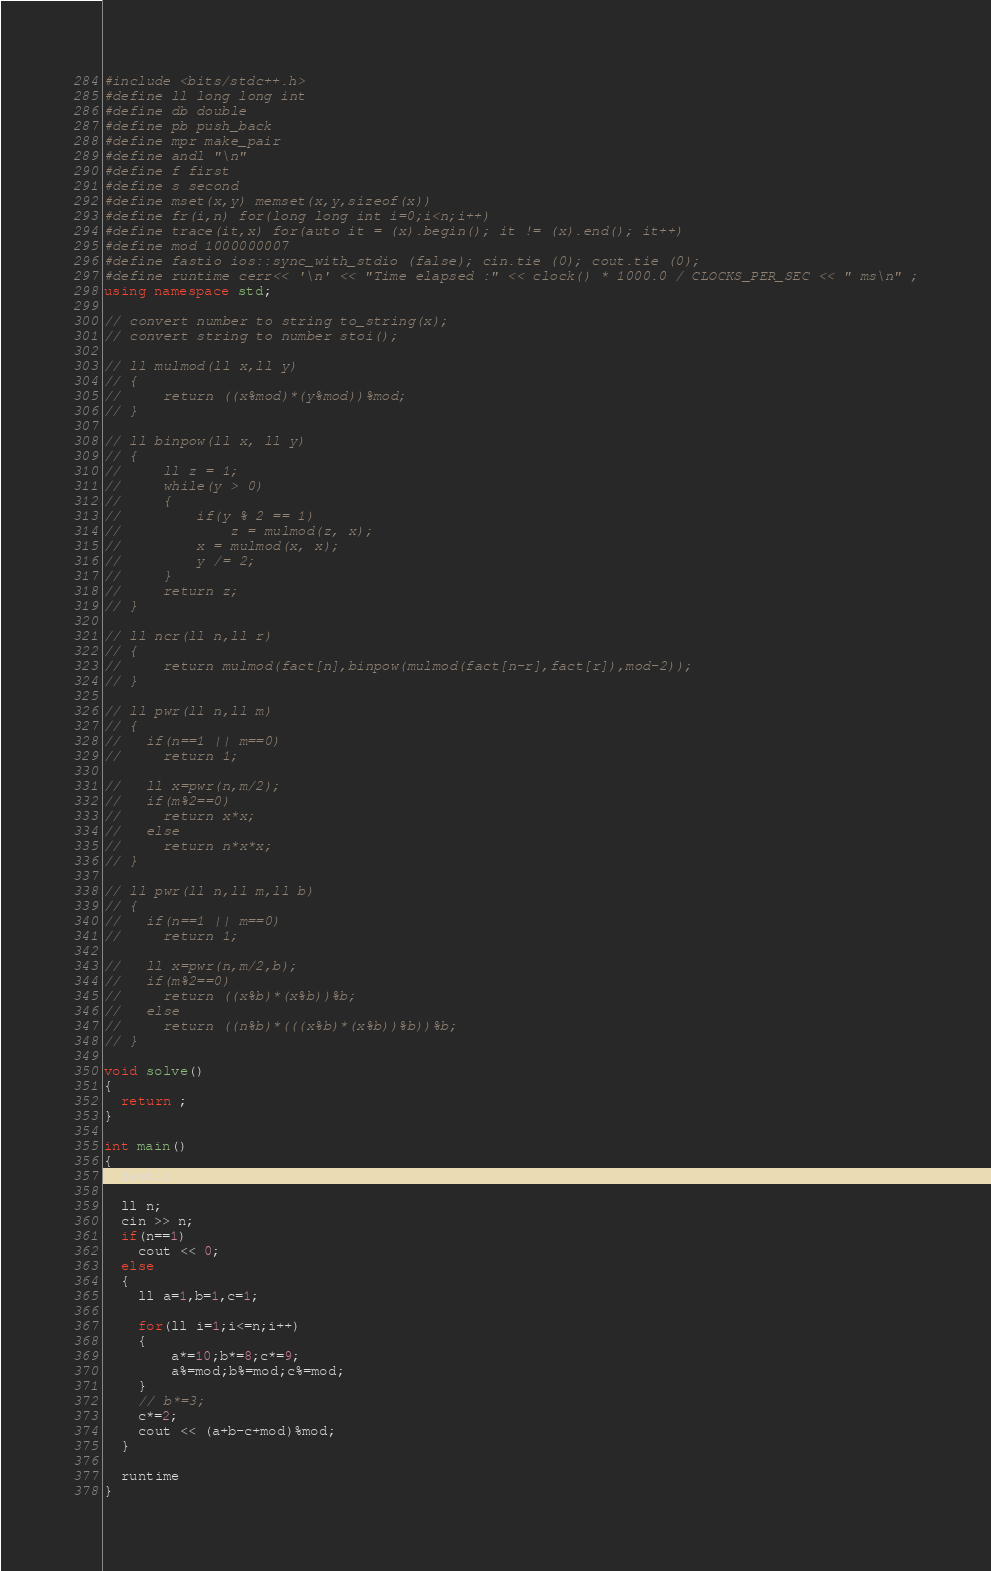Convert code to text. <code><loc_0><loc_0><loc_500><loc_500><_C++_>#include <bits/stdc++.h>
#define ll long long int
#define db double
#define pb push_back
#define mpr make_pair
#define andl "\n"
#define f first
#define s second
#define mset(x,y) memset(x,y,sizeof(x))
#define fr(i,n) for(long long int i=0;i<n;i++)
#define trace(it,x) for(auto it = (x).begin(); it != (x).end(); it++)
#define mod 1000000007
#define fastio ios::sync_with_stdio (false); cin.tie (0); cout.tie (0);
#define runtime cerr<< '\n' << "Time elapsed :" << clock() * 1000.0 / CLOCKS_PER_SEC << " ms\n" ;
using namespace std;
 
// convert number to string to_string(x);
// convert string to number stoi();
 
// ll mulmod(ll x,ll y)
// {
//     return ((x%mod)*(y%mod))%mod;
// }
 
// ll binpow(ll x, ll y)
// {
//     ll z = 1;
//     while(y > 0)
//     {
//         if(y % 2 == 1)
//             z = mulmod(z, x);
//         x = mulmod(x, x);
//         y /= 2;
//     }
//     return z;
// }
 
// ll ncr(ll n,ll r)
// {
//     return mulmod(fact[n],binpow(mulmod(fact[n-r],fact[r]),mod-2));
// }
 
// ll pwr(ll n,ll m)
// {
//   if(n==1 || m==0)
//     return 1;
 
//   ll x=pwr(n,m/2);
//   if(m%2==0)
//     return x*x;
//   else
//     return n*x*x;
// }
 
// ll pwr(ll n,ll m,ll b)
// {
//   if(n==1 || m==0)
//     return 1;
 
//   ll x=pwr(n,m/2,b);
//   if(m%2==0)
//     return ((x%b)*(x%b))%b;
//   else
//     return ((n%b)*(((x%b)*(x%b))%b))%b;
// }
 
void solve()
{
  return ;
}
 
int main()
{
  fastio
  
  ll n;
  cin >> n;
  if(n==1)
  	cout << 0;
  else
  {
  	ll a=1,b=1,c=1;

  	for(ll i=1;i<=n;i++)
  	{
  		a*=10;b*=8;c*=9;
  		a%=mod;b%=mod;c%=mod;
  	}
  	// b*=3;
  	c*=2;
  	cout << (a+b-c+mod)%mod;
  }
 
  runtime
}</code> 